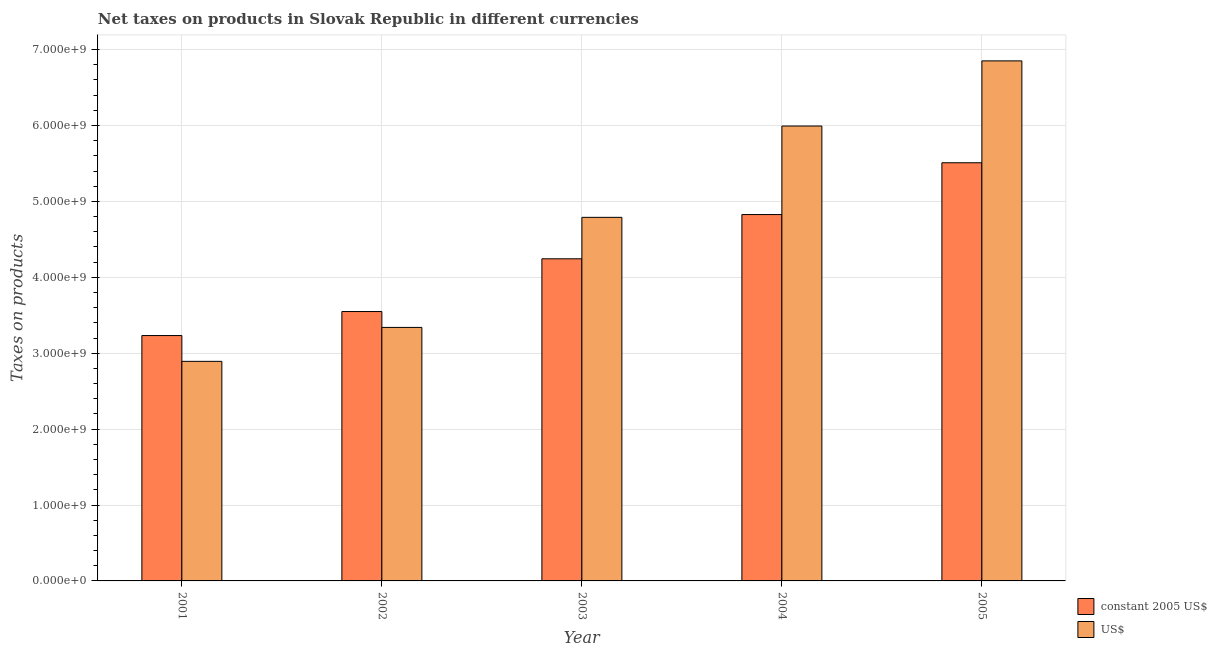How many different coloured bars are there?
Your answer should be compact. 2. In how many cases, is the number of bars for a given year not equal to the number of legend labels?
Your response must be concise. 0. What is the net taxes in us$ in 2002?
Offer a very short reply. 3.34e+09. Across all years, what is the maximum net taxes in us$?
Offer a terse response. 6.85e+09. Across all years, what is the minimum net taxes in us$?
Your response must be concise. 2.89e+09. In which year was the net taxes in us$ maximum?
Your answer should be compact. 2005. What is the total net taxes in us$ in the graph?
Your response must be concise. 2.39e+1. What is the difference between the net taxes in constant 2005 us$ in 2001 and that in 2005?
Give a very brief answer. -2.28e+09. What is the difference between the net taxes in constant 2005 us$ in 2005 and the net taxes in us$ in 2003?
Give a very brief answer. 1.27e+09. What is the average net taxes in us$ per year?
Your answer should be compact. 4.77e+09. In how many years, is the net taxes in us$ greater than 1200000000 units?
Your answer should be compact. 5. What is the ratio of the net taxes in us$ in 2002 to that in 2005?
Offer a very short reply. 0.49. Is the difference between the net taxes in us$ in 2001 and 2004 greater than the difference between the net taxes in constant 2005 us$ in 2001 and 2004?
Your response must be concise. No. What is the difference between the highest and the second highest net taxes in us$?
Your response must be concise. 8.58e+08. What is the difference between the highest and the lowest net taxes in constant 2005 us$?
Give a very brief answer. 2.28e+09. In how many years, is the net taxes in constant 2005 us$ greater than the average net taxes in constant 2005 us$ taken over all years?
Your response must be concise. 2. Is the sum of the net taxes in us$ in 2002 and 2004 greater than the maximum net taxes in constant 2005 us$ across all years?
Offer a terse response. Yes. What does the 1st bar from the left in 2004 represents?
Offer a terse response. Constant 2005 us$. What does the 2nd bar from the right in 2004 represents?
Make the answer very short. Constant 2005 us$. How many bars are there?
Ensure brevity in your answer.  10. Are all the bars in the graph horizontal?
Your answer should be compact. No. How many years are there in the graph?
Your response must be concise. 5. Does the graph contain grids?
Offer a very short reply. Yes. Where does the legend appear in the graph?
Give a very brief answer. Bottom right. What is the title of the graph?
Your answer should be very brief. Net taxes on products in Slovak Republic in different currencies. Does "Banks" appear as one of the legend labels in the graph?
Offer a terse response. No. What is the label or title of the Y-axis?
Ensure brevity in your answer.  Taxes on products. What is the Taxes on products of constant 2005 US$ in 2001?
Offer a terse response. 3.23e+09. What is the Taxes on products of US$ in 2001?
Give a very brief answer. 2.89e+09. What is the Taxes on products of constant 2005 US$ in 2002?
Offer a terse response. 3.55e+09. What is the Taxes on products in US$ in 2002?
Your answer should be very brief. 3.34e+09. What is the Taxes on products in constant 2005 US$ in 2003?
Your answer should be compact. 4.24e+09. What is the Taxes on products in US$ in 2003?
Your answer should be compact. 4.79e+09. What is the Taxes on products of constant 2005 US$ in 2004?
Give a very brief answer. 4.83e+09. What is the Taxes on products in US$ in 2004?
Provide a succinct answer. 5.99e+09. What is the Taxes on products in constant 2005 US$ in 2005?
Provide a succinct answer. 5.51e+09. What is the Taxes on products in US$ in 2005?
Make the answer very short. 6.85e+09. Across all years, what is the maximum Taxes on products of constant 2005 US$?
Provide a succinct answer. 5.51e+09. Across all years, what is the maximum Taxes on products of US$?
Give a very brief answer. 6.85e+09. Across all years, what is the minimum Taxes on products of constant 2005 US$?
Your answer should be very brief. 3.23e+09. Across all years, what is the minimum Taxes on products of US$?
Provide a short and direct response. 2.89e+09. What is the total Taxes on products of constant 2005 US$ in the graph?
Provide a short and direct response. 2.14e+1. What is the total Taxes on products in US$ in the graph?
Make the answer very short. 2.39e+1. What is the difference between the Taxes on products in constant 2005 US$ in 2001 and that in 2002?
Your answer should be very brief. -3.16e+08. What is the difference between the Taxes on products of US$ in 2001 and that in 2002?
Make the answer very short. -4.47e+08. What is the difference between the Taxes on products of constant 2005 US$ in 2001 and that in 2003?
Offer a very short reply. -1.01e+09. What is the difference between the Taxes on products of US$ in 2001 and that in 2003?
Offer a very short reply. -1.90e+09. What is the difference between the Taxes on products of constant 2005 US$ in 2001 and that in 2004?
Offer a terse response. -1.59e+09. What is the difference between the Taxes on products in US$ in 2001 and that in 2004?
Offer a terse response. -3.10e+09. What is the difference between the Taxes on products in constant 2005 US$ in 2001 and that in 2005?
Provide a short and direct response. -2.28e+09. What is the difference between the Taxes on products of US$ in 2001 and that in 2005?
Keep it short and to the point. -3.96e+09. What is the difference between the Taxes on products in constant 2005 US$ in 2002 and that in 2003?
Your response must be concise. -6.95e+08. What is the difference between the Taxes on products of US$ in 2002 and that in 2003?
Provide a short and direct response. -1.45e+09. What is the difference between the Taxes on products in constant 2005 US$ in 2002 and that in 2004?
Offer a terse response. -1.28e+09. What is the difference between the Taxes on products of US$ in 2002 and that in 2004?
Provide a short and direct response. -2.65e+09. What is the difference between the Taxes on products in constant 2005 US$ in 2002 and that in 2005?
Your response must be concise. -1.96e+09. What is the difference between the Taxes on products in US$ in 2002 and that in 2005?
Keep it short and to the point. -3.51e+09. What is the difference between the Taxes on products in constant 2005 US$ in 2003 and that in 2004?
Your response must be concise. -5.83e+08. What is the difference between the Taxes on products of US$ in 2003 and that in 2004?
Your answer should be very brief. -1.20e+09. What is the difference between the Taxes on products of constant 2005 US$ in 2003 and that in 2005?
Provide a succinct answer. -1.27e+09. What is the difference between the Taxes on products in US$ in 2003 and that in 2005?
Keep it short and to the point. -2.06e+09. What is the difference between the Taxes on products of constant 2005 US$ in 2004 and that in 2005?
Give a very brief answer. -6.82e+08. What is the difference between the Taxes on products of US$ in 2004 and that in 2005?
Give a very brief answer. -8.58e+08. What is the difference between the Taxes on products in constant 2005 US$ in 2001 and the Taxes on products in US$ in 2002?
Your answer should be compact. -1.07e+08. What is the difference between the Taxes on products of constant 2005 US$ in 2001 and the Taxes on products of US$ in 2003?
Provide a succinct answer. -1.56e+09. What is the difference between the Taxes on products of constant 2005 US$ in 2001 and the Taxes on products of US$ in 2004?
Make the answer very short. -2.76e+09. What is the difference between the Taxes on products in constant 2005 US$ in 2001 and the Taxes on products in US$ in 2005?
Give a very brief answer. -3.62e+09. What is the difference between the Taxes on products of constant 2005 US$ in 2002 and the Taxes on products of US$ in 2003?
Keep it short and to the point. -1.24e+09. What is the difference between the Taxes on products of constant 2005 US$ in 2002 and the Taxes on products of US$ in 2004?
Ensure brevity in your answer.  -2.44e+09. What is the difference between the Taxes on products of constant 2005 US$ in 2002 and the Taxes on products of US$ in 2005?
Keep it short and to the point. -3.30e+09. What is the difference between the Taxes on products of constant 2005 US$ in 2003 and the Taxes on products of US$ in 2004?
Make the answer very short. -1.75e+09. What is the difference between the Taxes on products of constant 2005 US$ in 2003 and the Taxes on products of US$ in 2005?
Your answer should be very brief. -2.61e+09. What is the difference between the Taxes on products of constant 2005 US$ in 2004 and the Taxes on products of US$ in 2005?
Offer a very short reply. -2.02e+09. What is the average Taxes on products in constant 2005 US$ per year?
Your answer should be compact. 4.27e+09. What is the average Taxes on products in US$ per year?
Your answer should be very brief. 4.77e+09. In the year 2001, what is the difference between the Taxes on products of constant 2005 US$ and Taxes on products of US$?
Your answer should be very brief. 3.40e+08. In the year 2002, what is the difference between the Taxes on products in constant 2005 US$ and Taxes on products in US$?
Offer a very short reply. 2.09e+08. In the year 2003, what is the difference between the Taxes on products in constant 2005 US$ and Taxes on products in US$?
Give a very brief answer. -5.46e+08. In the year 2004, what is the difference between the Taxes on products of constant 2005 US$ and Taxes on products of US$?
Offer a terse response. -1.17e+09. In the year 2005, what is the difference between the Taxes on products of constant 2005 US$ and Taxes on products of US$?
Offer a terse response. -1.34e+09. What is the ratio of the Taxes on products of constant 2005 US$ in 2001 to that in 2002?
Your answer should be very brief. 0.91. What is the ratio of the Taxes on products in US$ in 2001 to that in 2002?
Your response must be concise. 0.87. What is the ratio of the Taxes on products in constant 2005 US$ in 2001 to that in 2003?
Your response must be concise. 0.76. What is the ratio of the Taxes on products in US$ in 2001 to that in 2003?
Keep it short and to the point. 0.6. What is the ratio of the Taxes on products in constant 2005 US$ in 2001 to that in 2004?
Your answer should be compact. 0.67. What is the ratio of the Taxes on products in US$ in 2001 to that in 2004?
Offer a very short reply. 0.48. What is the ratio of the Taxes on products of constant 2005 US$ in 2001 to that in 2005?
Ensure brevity in your answer.  0.59. What is the ratio of the Taxes on products of US$ in 2001 to that in 2005?
Give a very brief answer. 0.42. What is the ratio of the Taxes on products in constant 2005 US$ in 2002 to that in 2003?
Offer a terse response. 0.84. What is the ratio of the Taxes on products in US$ in 2002 to that in 2003?
Make the answer very short. 0.7. What is the ratio of the Taxes on products in constant 2005 US$ in 2002 to that in 2004?
Offer a terse response. 0.74. What is the ratio of the Taxes on products of US$ in 2002 to that in 2004?
Provide a succinct answer. 0.56. What is the ratio of the Taxes on products in constant 2005 US$ in 2002 to that in 2005?
Offer a terse response. 0.64. What is the ratio of the Taxes on products in US$ in 2002 to that in 2005?
Your response must be concise. 0.49. What is the ratio of the Taxes on products in constant 2005 US$ in 2003 to that in 2004?
Provide a short and direct response. 0.88. What is the ratio of the Taxes on products of US$ in 2003 to that in 2004?
Offer a very short reply. 0.8. What is the ratio of the Taxes on products of constant 2005 US$ in 2003 to that in 2005?
Provide a succinct answer. 0.77. What is the ratio of the Taxes on products in US$ in 2003 to that in 2005?
Provide a succinct answer. 0.7. What is the ratio of the Taxes on products in constant 2005 US$ in 2004 to that in 2005?
Provide a short and direct response. 0.88. What is the ratio of the Taxes on products in US$ in 2004 to that in 2005?
Your answer should be very brief. 0.87. What is the difference between the highest and the second highest Taxes on products of constant 2005 US$?
Offer a terse response. 6.82e+08. What is the difference between the highest and the second highest Taxes on products of US$?
Give a very brief answer. 8.58e+08. What is the difference between the highest and the lowest Taxes on products in constant 2005 US$?
Give a very brief answer. 2.28e+09. What is the difference between the highest and the lowest Taxes on products in US$?
Make the answer very short. 3.96e+09. 